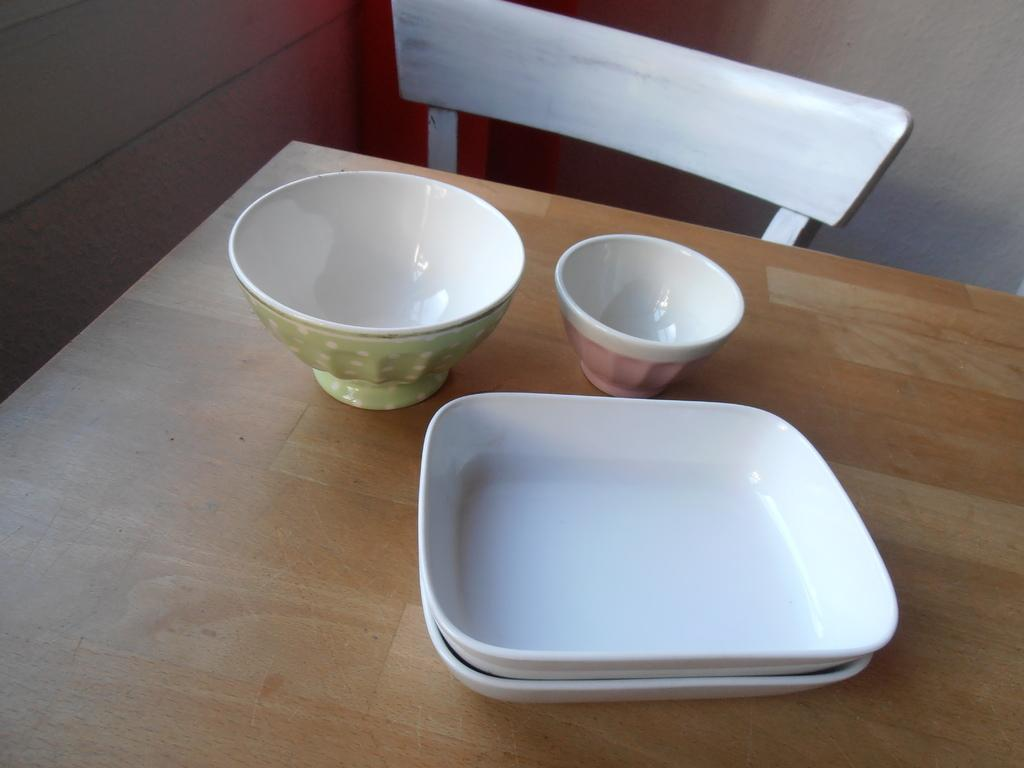What type of furniture is present in the image? There is a table in the image. What items are on the table? The table has plates and bowls on it. Is there any seating associated with the table? Yes, there is a chair behind the table. What can be seen in the background of the image? There is a wall in the background of the image. What type of rock is being used as a table in the image? There is no rock being used as a table in the image; it is a regular table made of a different material. 